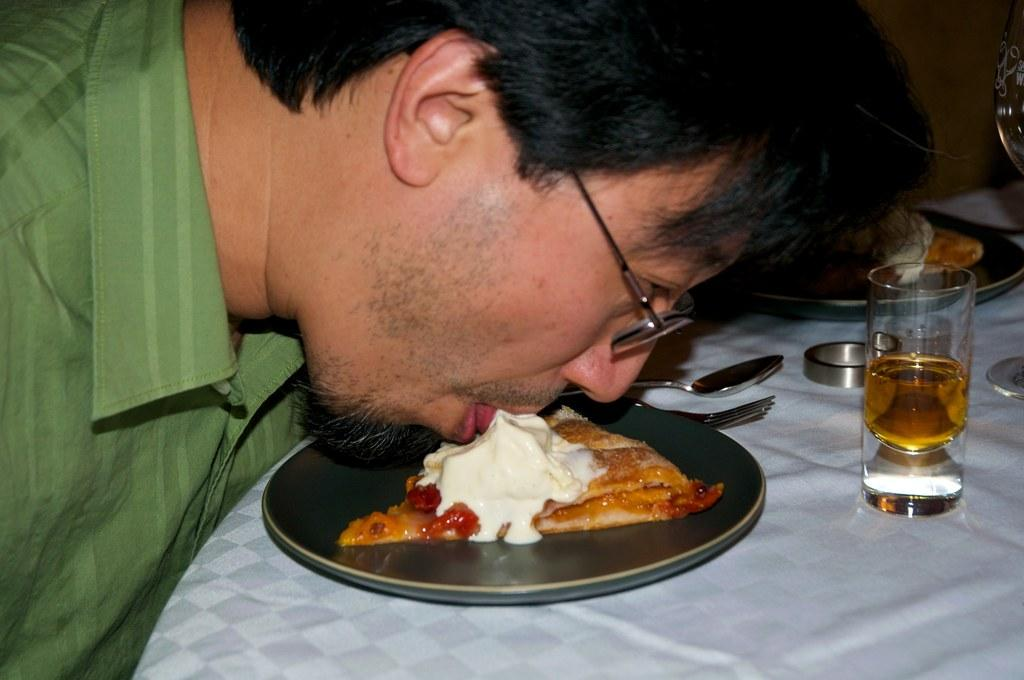What is the main object in the center of the image? There is a table in the center of the image. What utensils can be seen on the table? Spoons are present on the table. What else is on the table besides the spoons? A glass and a food item on a plate are also on the table. What is the man on the left side of the image doing? The man is tasting a food on the left side of the image. What type of camera is the fireman using to take a picture of the bulb in the image? There is no camera, fireman, or bulb present in the image. 